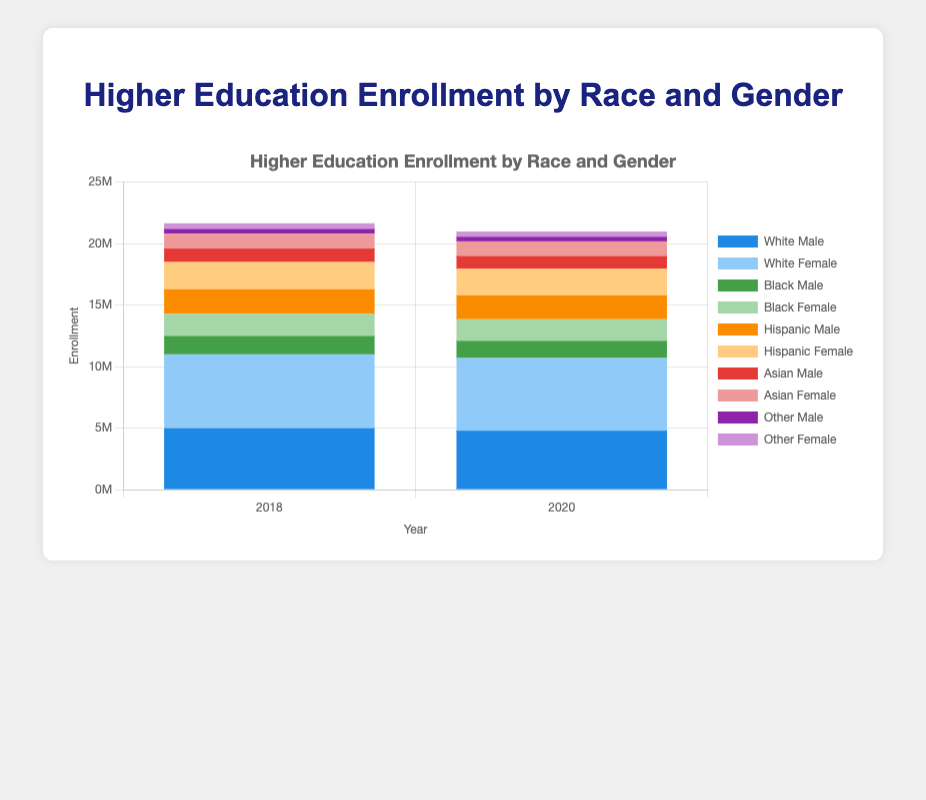How did the enrollment of Hispanic females change from 2018 to 2020? To find the change in enrollment, subtract the 2018 enrollment of Hispanic females (2,200,000) from the 2020 enrollment of Hispanic females (2,150,000). \(2,150,000 - 2,200,000 = -50,000\)
Answer: -50,000 What was the total enrollment for Black males and females in 2018? To find the total enrollment, sum the enrollment of Black males (1,500,000) and Black females (1,800,000) in 2018. \(1,500,000 + 1,800,000 = 3,300,000\)
Answer: 3,300,000 Which gender has higher enrollment among Asian students in 2020? Compare the enrollment numbers for Asian males (1,050,000) and Asian females (1,180,000) in 2020. Since 1,180,000 > 1,050,000, Asian females have higher enrollment.
Answer: Female By how much did the total enrollment for 'Other' race increase from 2018 to 2020? To find the increase, subtract the total enrollment in 2018 (400,000 for males + 450,000 for females = 850,000) from the total enrollment in 2020 (380,000 for males + 420,000 for females = 800,000). \(800,000 - 850,000 = -50,000\)
Answer: -50,000 What's the combined enrollment of White males and females in 2020? Sum the enrollment of White males (4,800,000) and White females (5,900,000) in 2020. \(4,800,000 + 5,900,000 = 10,700,000\)
Answer: 10,700,000 Which year had higher total enrollment for all races combined, 2018 or 2020? Sum the enrollment for all races and genders in both years. For 2018: (5,000,000 + 6,000,000 + 1,500,000 + 1,800,000 + 2,000,000 + 2,200,000 + 1,100,000 + 1,200,000 + 400,000 + 450,000 = 21,650,000). For 2020: (4,800,000 + 5,900,000 + 1,400,000 + 1,750,000 + 1,950,000 + 2,150,000 + 1,050,000 + 1,180,000 + 380,000 + 420,000 = 20,980,000). 2018 had higher total enrollment.
Answer: 2018 Did enrollment of Asian males increase or decrease from 2018 to 2020? Compare enrollment of Asian males in 2018 (1,100,000) and 2020 (1,050,000). Since 1,100,000 > 1,050,000, enrollment decreased.
Answer: Decrease What is the visual difference between the enrollment bars for White males and females in 2018? The bar for White females (colored lighter blue) in 2018 is taller than the bar for White males (colored darker blue) indicating higher enrollment by 1,000,000.
Answer: Taller by 1,000,000 